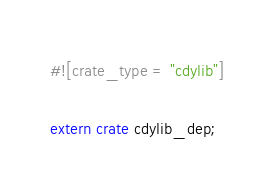<code> <loc_0><loc_0><loc_500><loc_500><_Rust_>#![crate_type = "cdylib"]

extern crate cdylib_dep;
</code> 